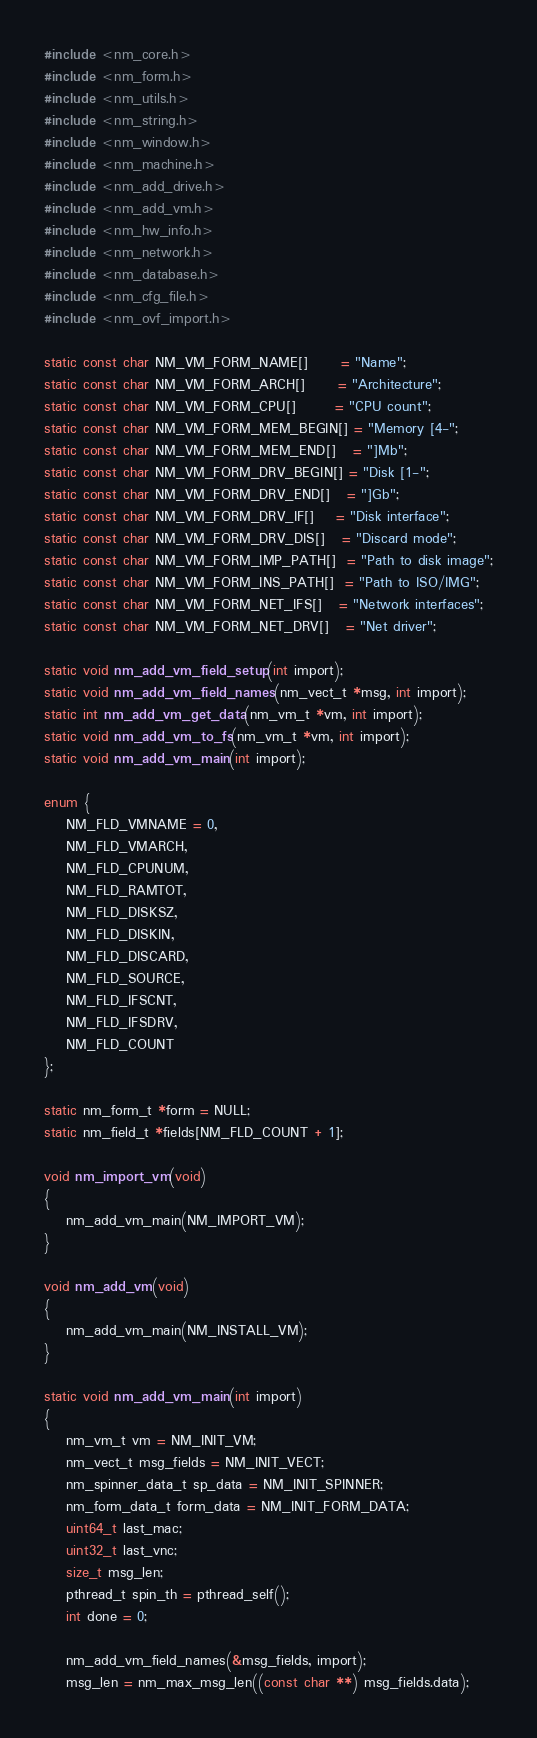<code> <loc_0><loc_0><loc_500><loc_500><_C_>#include <nm_core.h>
#include <nm_form.h>
#include <nm_utils.h>
#include <nm_string.h>
#include <nm_window.h>
#include <nm_machine.h>
#include <nm_add_drive.h>
#include <nm_add_vm.h>
#include <nm_hw_info.h>
#include <nm_network.h>
#include <nm_database.h>
#include <nm_cfg_file.h>
#include <nm_ovf_import.h>

static const char NM_VM_FORM_NAME[]      = "Name";
static const char NM_VM_FORM_ARCH[]      = "Architecture";
static const char NM_VM_FORM_CPU[]       = "CPU count";
static const char NM_VM_FORM_MEM_BEGIN[] = "Memory [4-";
static const char NM_VM_FORM_MEM_END[]   = "]Mb";
static const char NM_VM_FORM_DRV_BEGIN[] = "Disk [1-";
static const char NM_VM_FORM_DRV_END[]   = "]Gb";
static const char NM_VM_FORM_DRV_IF[]    = "Disk interface";
static const char NM_VM_FORM_DRV_DIS[]   = "Discard mode";
static const char NM_VM_FORM_IMP_PATH[]  = "Path to disk image";
static const char NM_VM_FORM_INS_PATH[]  = "Path to ISO/IMG";
static const char NM_VM_FORM_NET_IFS[]   = "Network interfaces";
static const char NM_VM_FORM_NET_DRV[]   = "Net driver";

static void nm_add_vm_field_setup(int import);
static void nm_add_vm_field_names(nm_vect_t *msg, int import);
static int nm_add_vm_get_data(nm_vm_t *vm, int import);
static void nm_add_vm_to_fs(nm_vm_t *vm, int import);
static void nm_add_vm_main(int import);

enum {
    NM_FLD_VMNAME = 0,
    NM_FLD_VMARCH,
    NM_FLD_CPUNUM,
    NM_FLD_RAMTOT,
    NM_FLD_DISKSZ,
    NM_FLD_DISKIN,
    NM_FLD_DISCARD,
    NM_FLD_SOURCE,
    NM_FLD_IFSCNT,
    NM_FLD_IFSDRV,
    NM_FLD_COUNT
};

static nm_form_t *form = NULL;
static nm_field_t *fields[NM_FLD_COUNT + 1];

void nm_import_vm(void)
{
    nm_add_vm_main(NM_IMPORT_VM);
}

void nm_add_vm(void)
{
    nm_add_vm_main(NM_INSTALL_VM);
}

static void nm_add_vm_main(int import)
{
    nm_vm_t vm = NM_INIT_VM;
    nm_vect_t msg_fields = NM_INIT_VECT;
    nm_spinner_data_t sp_data = NM_INIT_SPINNER;
    nm_form_data_t form_data = NM_INIT_FORM_DATA;
    uint64_t last_mac;
    uint32_t last_vnc;
    size_t msg_len;
    pthread_t spin_th = pthread_self();
    int done = 0;

    nm_add_vm_field_names(&msg_fields, import);
    msg_len = nm_max_msg_len((const char **) msg_fields.data);
</code> 